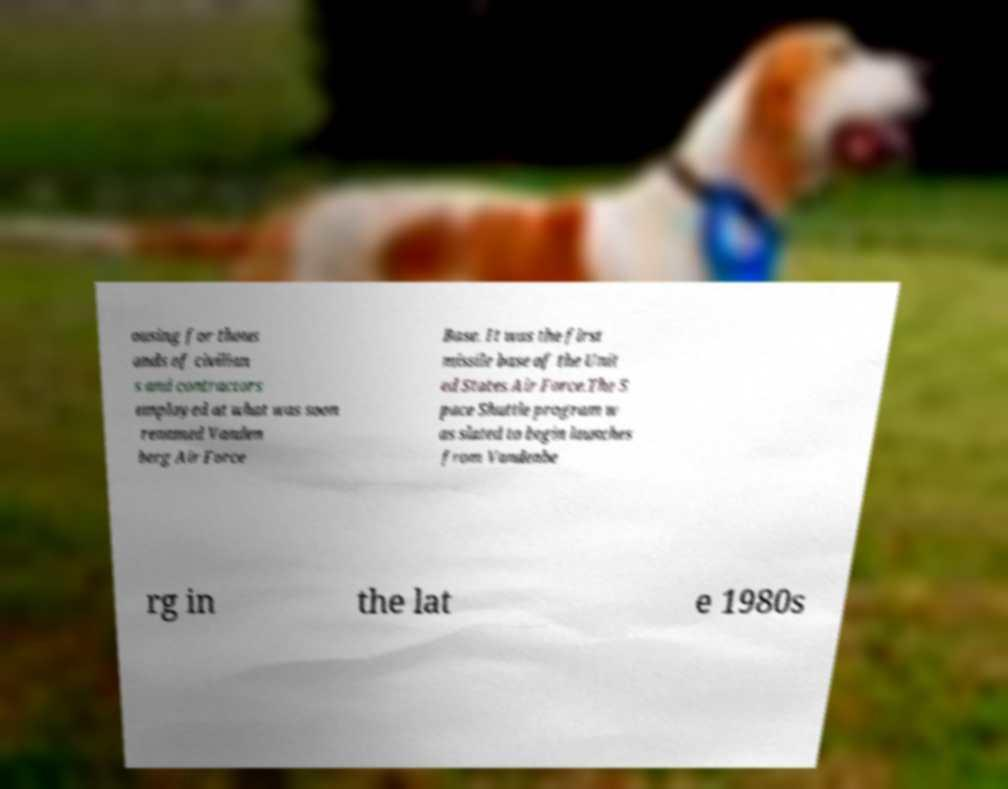Could you extract and type out the text from this image? ousing for thous ands of civilian s and contractors employed at what was soon renamed Vanden berg Air Force Base. It was the first missile base of the Unit ed States Air Force.The S pace Shuttle program w as slated to begin launches from Vandenbe rg in the lat e 1980s 